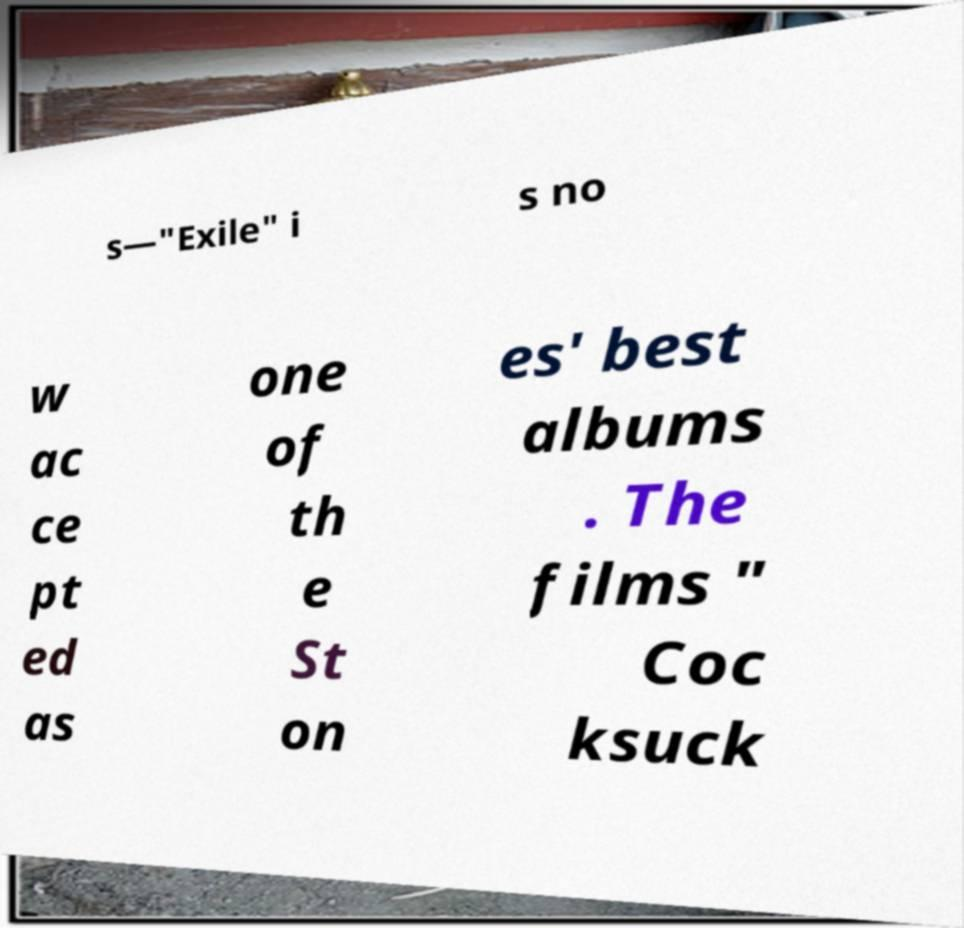Could you assist in decoding the text presented in this image and type it out clearly? s—"Exile" i s no w ac ce pt ed as one of th e St on es' best albums . The films " Coc ksuck 